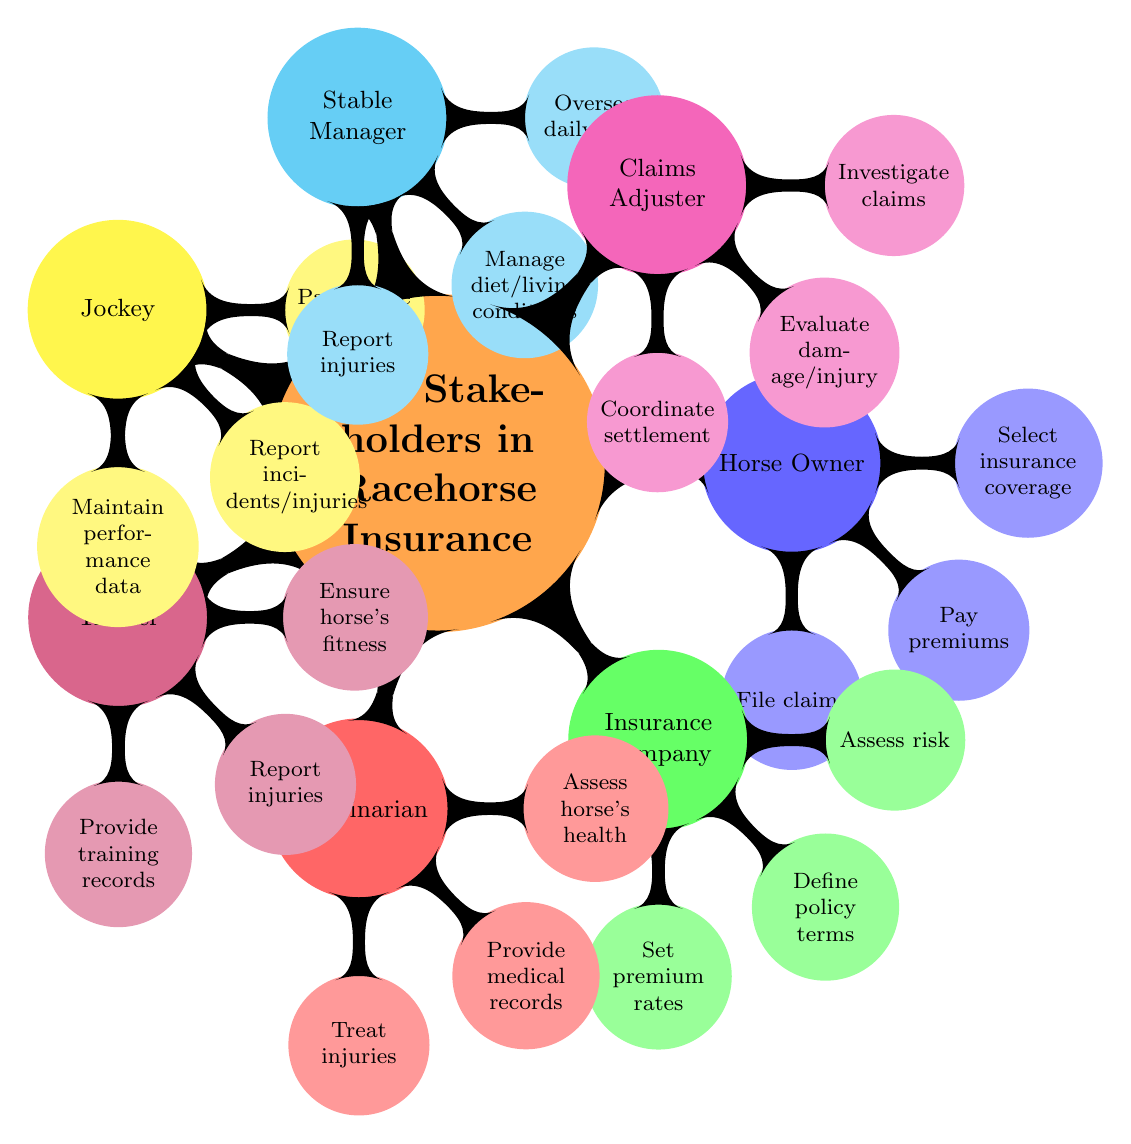What is the role of the Horse Owner? The Horse Owner is identified as the primary insured party in the diagram. This information is directly indicated under the Horse Owner node.
Answer: Primary Insured Party How many responsibilities does the Veterinarian have? The Veterinarian node has three responsibilities listed as sub-nodes. By counting the sub-nodes under Veterinarian, the answer is found.
Answer: 3 What are the responsibilities of the Trainer? The Trainer node directly lists three responsibilities: Ensure horse’s fitness, Report injuries, Provide training records. These are visible as sub-nodes under Trainer.
Answer: Ensure horse’s fitness, Report injuries, Provide training records Which stakeholder assesses risk? The responsibility of assessing risk is specifically linked to the Insurance Company node found directly under that stakeholder.
Answer: Insurance Company What is the relationship between Claims Adjuster and Insurance Company? Both nodes are connected as stakeholders in the racehorse insurance ecosystem, but Claims Adjuster specifically deals with claims that arise from policies defined by the Insurance Company. This relationship shows dependency regarding claims management.
Answer: Claims Adjuster manages claims of Insurance Company How many stakeholders are involved in Racehorse Insurance? The main node indicates there are seven different stakeholders in total. By counting each child node under the Key Stakeholders in Racehorse Insurance node, the total is determined.
Answer: 7 What does the Stable Manager oversee? The responsibilities listed under the Stable Manager node indicate overseeing daily care, which is directly mentioned in the diagram.
Answer: Daily care What are the responsibilities of the Jockey in relation to horse performance? The responsibilities under the Jockey node include maintaining the horse's race performance data and reporting incidents/injuries, which are two specific duties that directly relate to horse performance.
Answer: Maintain horse's race performance data, Report incidents/injuries Who provides medical records? The Veterinarian is specified as the stakeholder responsible for providing medical records in the diagram, which is directly indicated under the Veterinarian node.
Answer: Veterinarian 